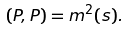<formula> <loc_0><loc_0><loc_500><loc_500>( P , P ) = m ^ { 2 } ( s ) .</formula> 